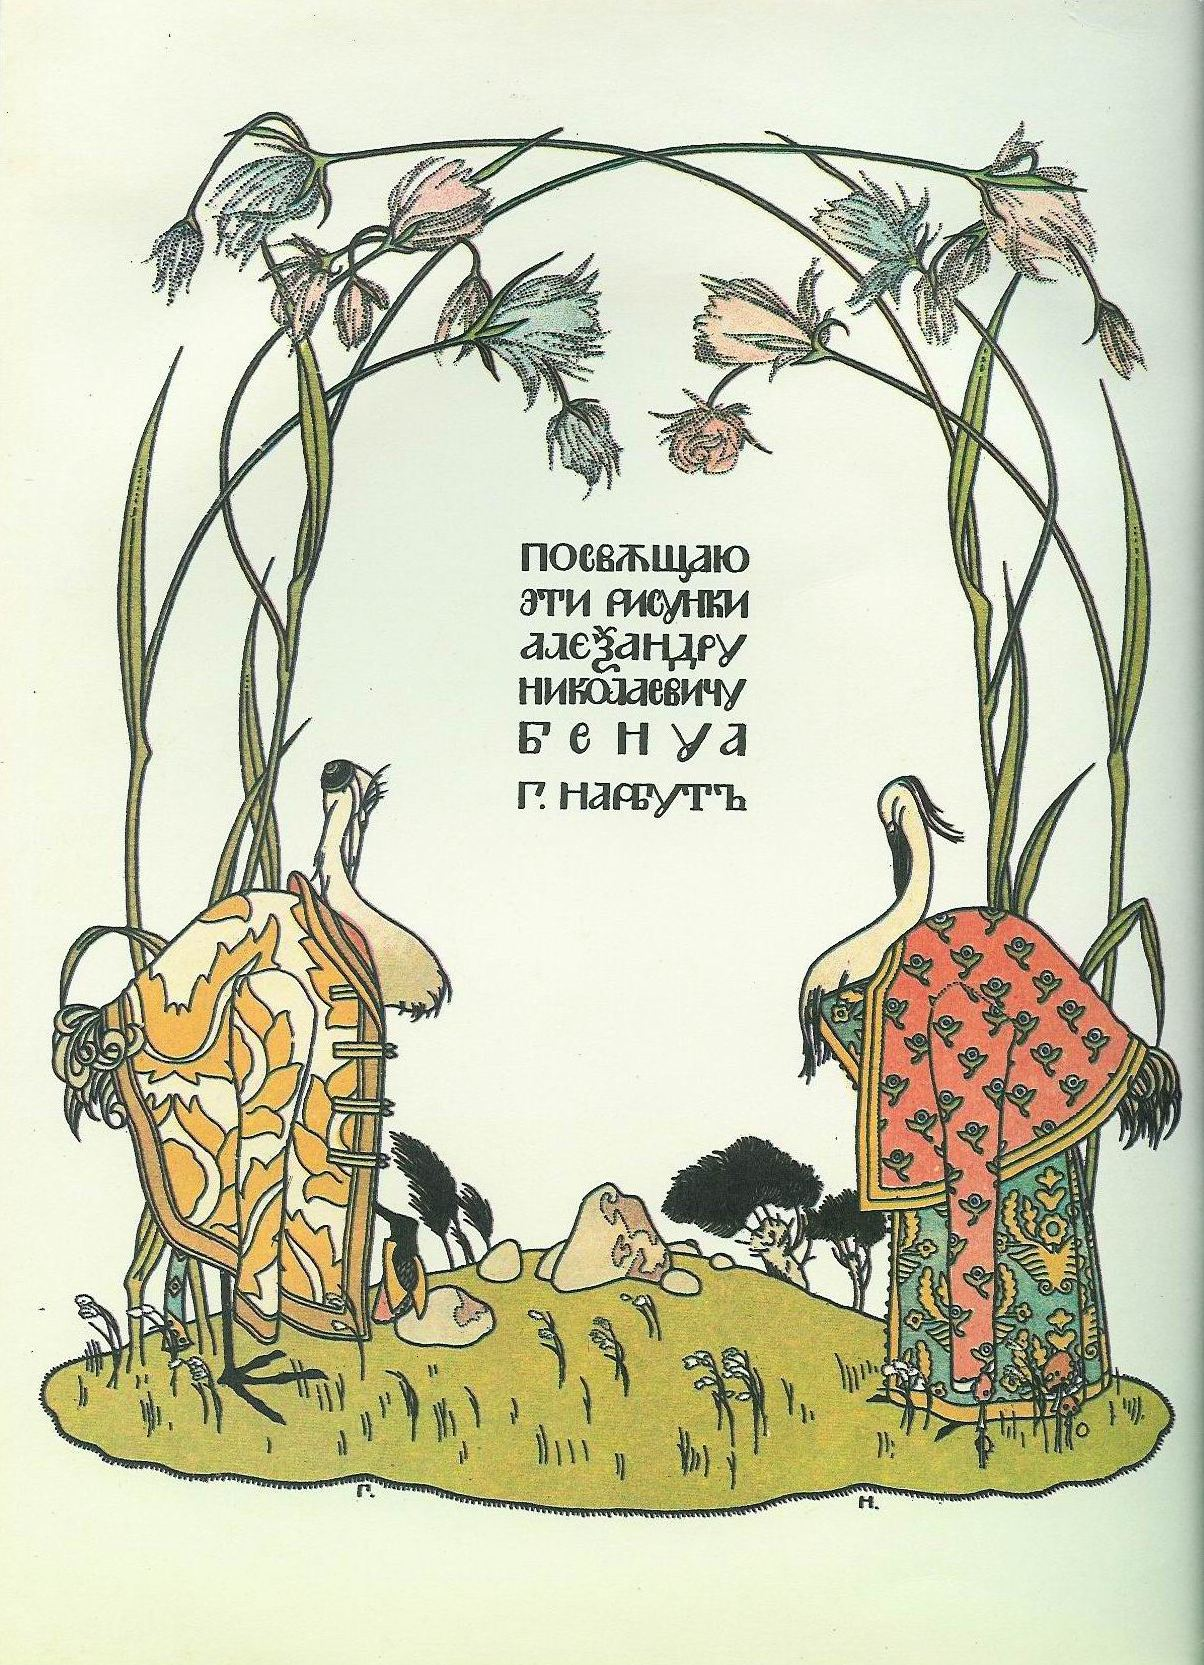Can you describe the main features of this image for me? The image presents a charming illustration reminiscent of a Russian folk tale, capturing the essence of Art Nouveau style. Two intricately designed houses, adorned with elaborate patterns, stand side by side under a beautifully crafted archway of gently curving green stems intertwined with delicate pink flowers. The pale green background enhances the atmosphere of tranquility and harmony. Notably, two white storks draped in patterned garments add a whimsical touch to the scene. The text in the middle, surrounded by flourishing organic elements, invokes a sense of tradition and storytelling. This artwork beautifully blends the natural world with intricate design, embodying the rich heritage of Russian folk art. 